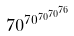Convert formula to latex. <formula><loc_0><loc_0><loc_500><loc_500>7 0 ^ { 7 0 ^ { 7 0 ^ { 7 0 ^ { 7 6 } } } }</formula> 